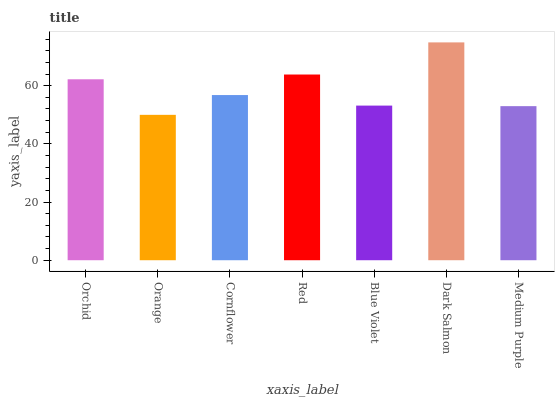Is Orange the minimum?
Answer yes or no. Yes. Is Dark Salmon the maximum?
Answer yes or no. Yes. Is Cornflower the minimum?
Answer yes or no. No. Is Cornflower the maximum?
Answer yes or no. No. Is Cornflower greater than Orange?
Answer yes or no. Yes. Is Orange less than Cornflower?
Answer yes or no. Yes. Is Orange greater than Cornflower?
Answer yes or no. No. Is Cornflower less than Orange?
Answer yes or no. No. Is Cornflower the high median?
Answer yes or no. Yes. Is Cornflower the low median?
Answer yes or no. Yes. Is Blue Violet the high median?
Answer yes or no. No. Is Orange the low median?
Answer yes or no. No. 